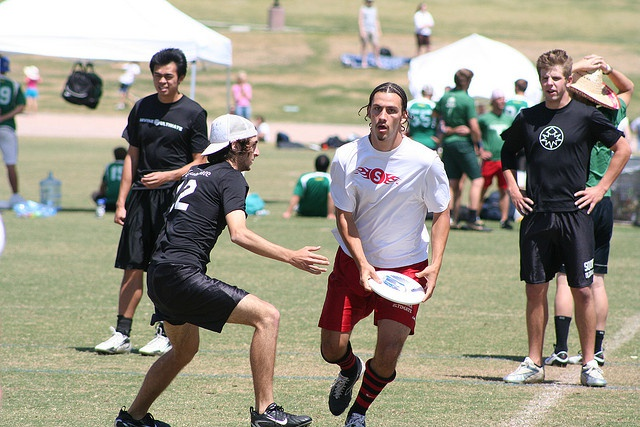Describe the objects in this image and their specific colors. I can see people in darkgray, maroon, lavender, and black tones, people in darkgray, black, gray, and white tones, people in darkgray, black, gray, lightpink, and brown tones, people in darkgray, black, gray, white, and maroon tones, and people in darkgray, black, lightgray, and lightpink tones in this image. 